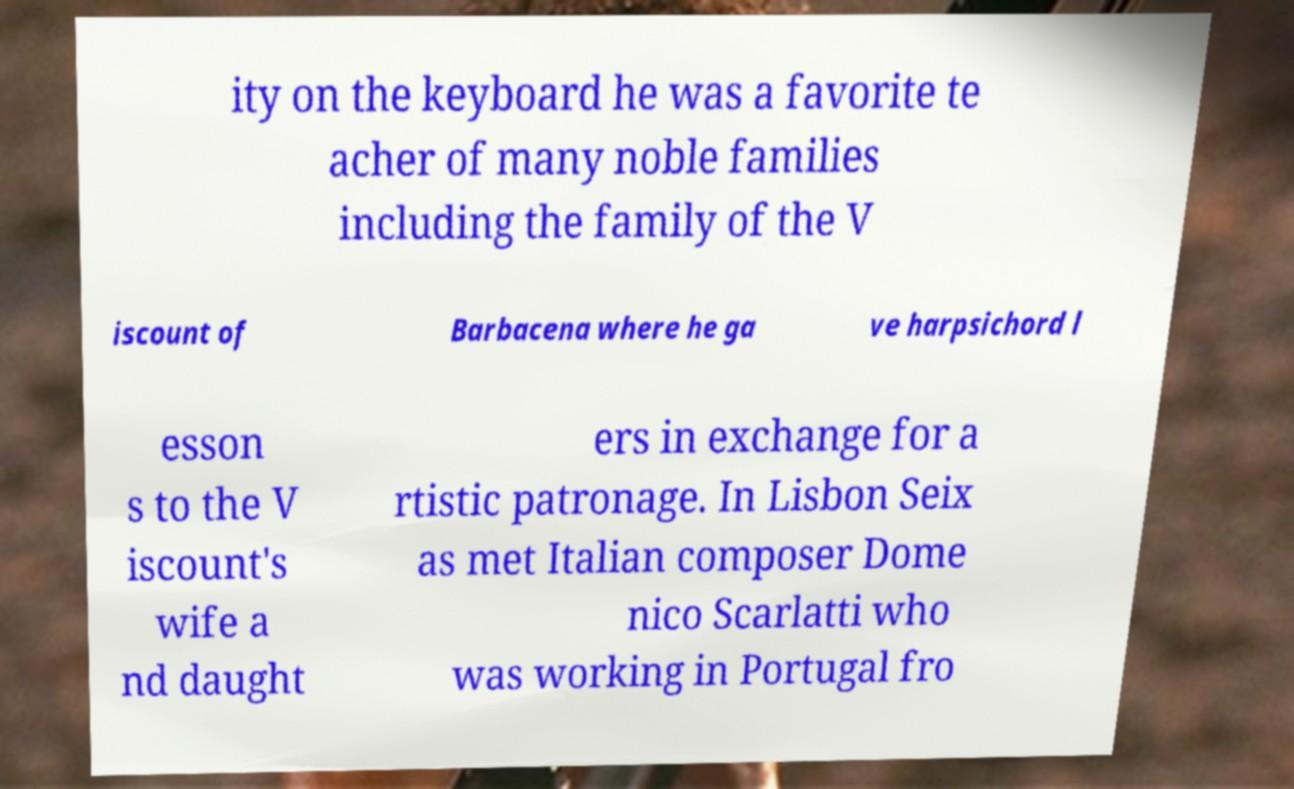There's text embedded in this image that I need extracted. Can you transcribe it verbatim? ity on the keyboard he was a favorite te acher of many noble families including the family of the V iscount of Barbacena where he ga ve harpsichord l esson s to the V iscount's wife a nd daught ers in exchange for a rtistic patronage. In Lisbon Seix as met Italian composer Dome nico Scarlatti who was working in Portugal fro 